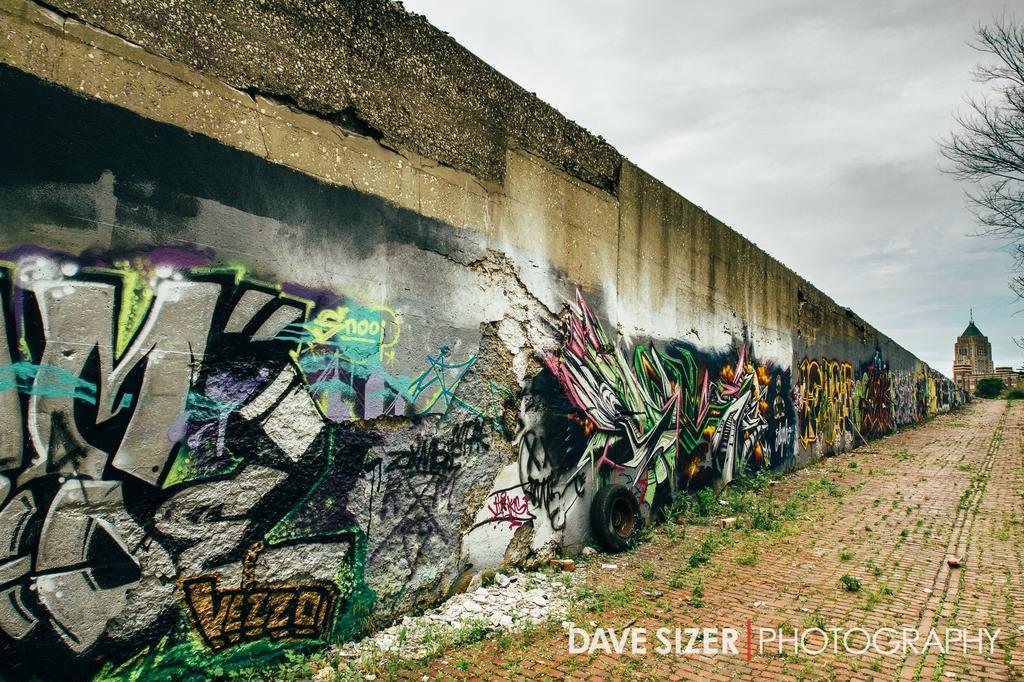How would you summarize this image in a sentence or two? In the foreground of this image, there are graffiti paintings on the wall which is in the left side. On the right, there is the path. In the background, there is a building. On the top, there is tree, cloud and the sky. 